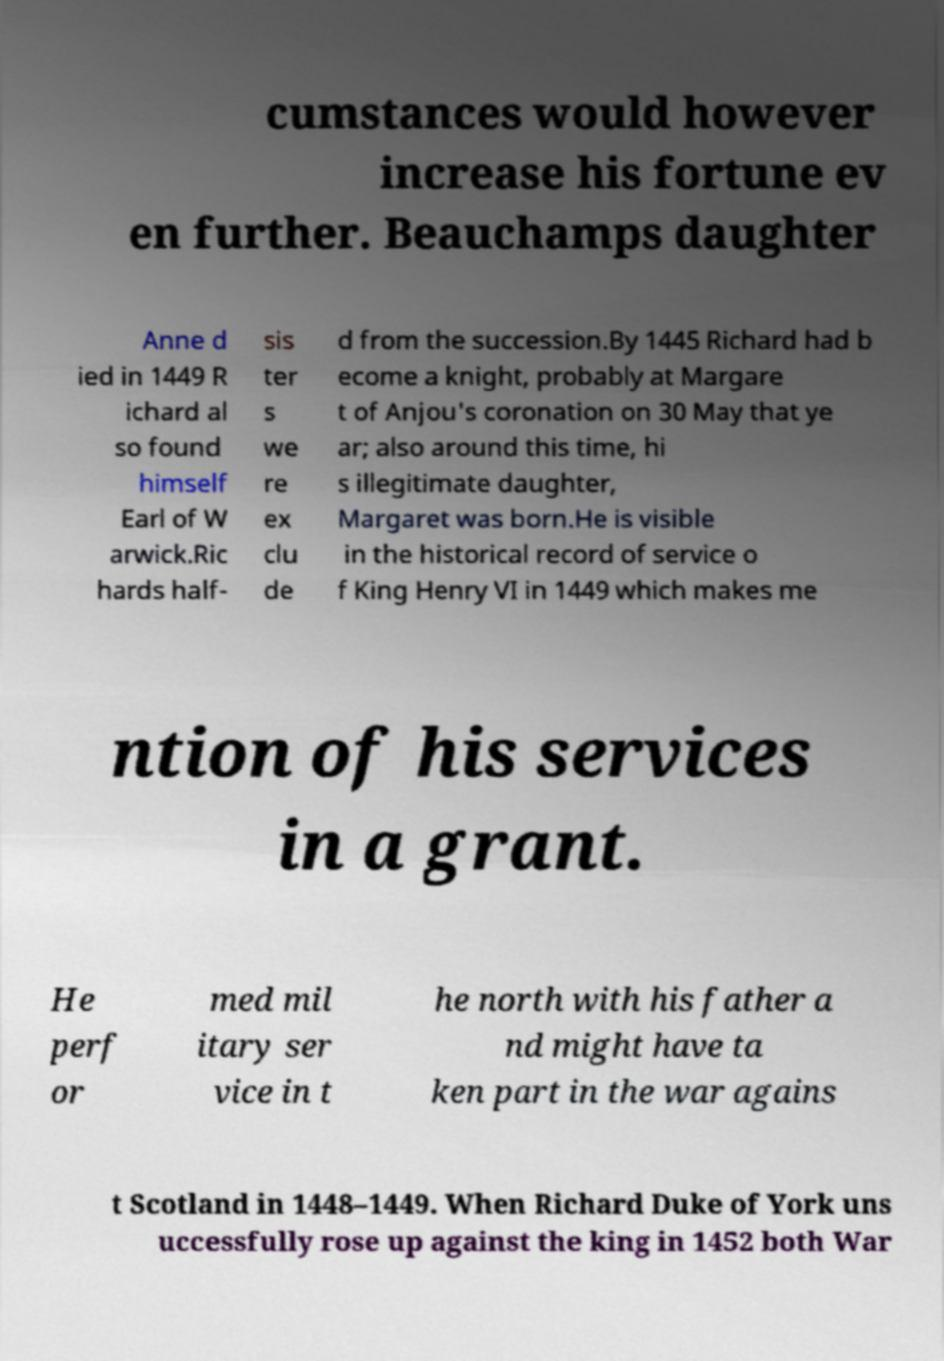Please read and relay the text visible in this image. What does it say? cumstances would however increase his fortune ev en further. Beauchamps daughter Anne d ied in 1449 R ichard al so found himself Earl of W arwick.Ric hards half- sis ter s we re ex clu de d from the succession.By 1445 Richard had b ecome a knight, probably at Margare t of Anjou's coronation on 30 May that ye ar; also around this time, hi s illegitimate daughter, Margaret was born.He is visible in the historical record of service o f King Henry VI in 1449 which makes me ntion of his services in a grant. He perf or med mil itary ser vice in t he north with his father a nd might have ta ken part in the war agains t Scotland in 1448–1449. When Richard Duke of York uns uccessfully rose up against the king in 1452 both War 